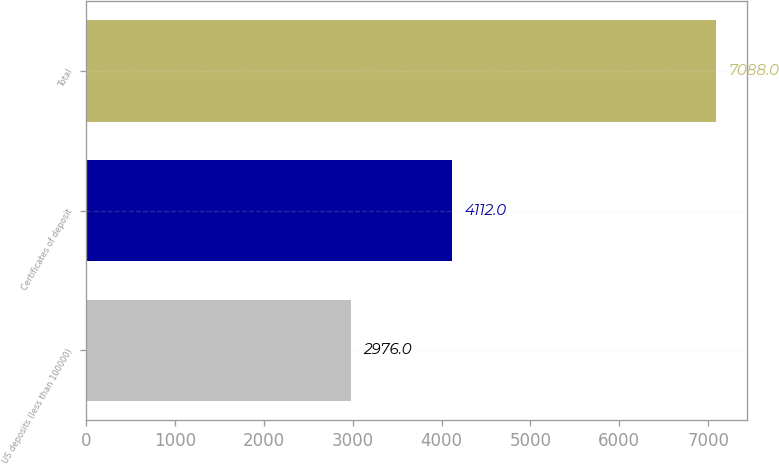Convert chart. <chart><loc_0><loc_0><loc_500><loc_500><bar_chart><fcel>US deposits (less than 100000)<fcel>Certificates of deposit<fcel>Total<nl><fcel>2976<fcel>4112<fcel>7088<nl></chart> 